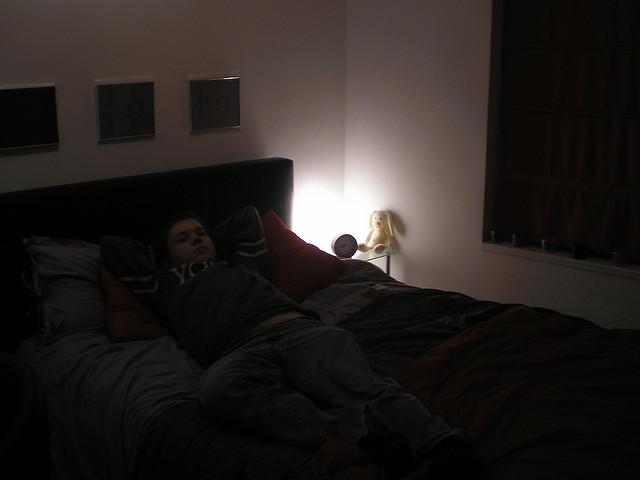The boy is most likely doing what? sleeping 